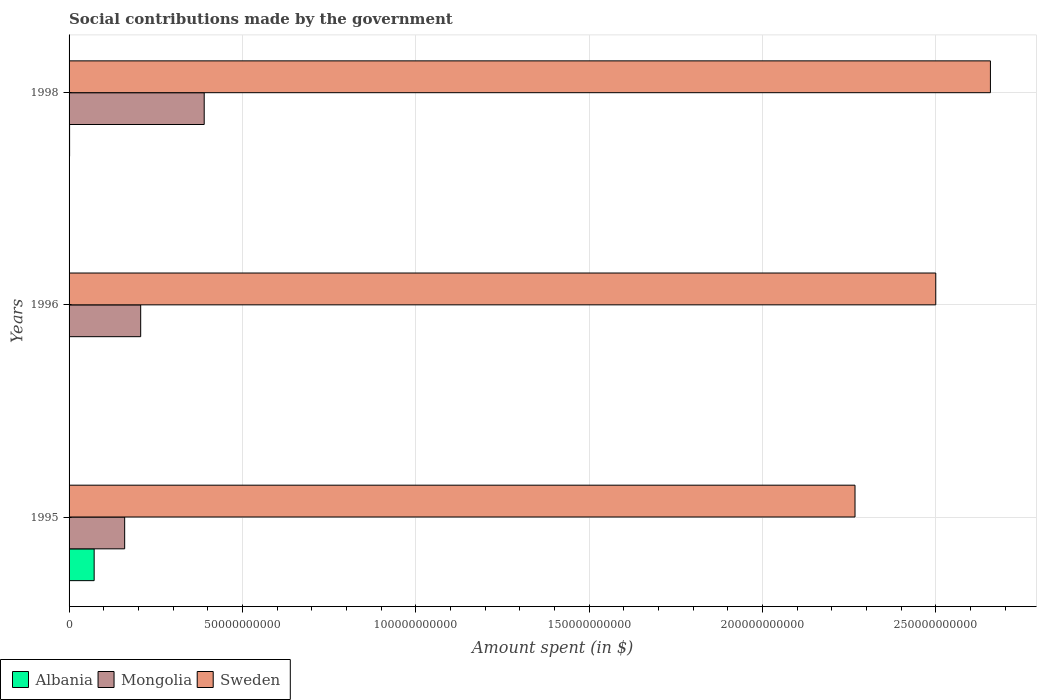How many different coloured bars are there?
Offer a terse response. 3. Are the number of bars per tick equal to the number of legend labels?
Your response must be concise. Yes. Are the number of bars on each tick of the Y-axis equal?
Your answer should be compact. Yes. What is the label of the 1st group of bars from the top?
Keep it short and to the point. 1998. In how many cases, is the number of bars for a given year not equal to the number of legend labels?
Your answer should be very brief. 0. What is the amount spent on social contributions in Mongolia in 1996?
Keep it short and to the point. 2.07e+1. Across all years, what is the maximum amount spent on social contributions in Albania?
Give a very brief answer. 7.24e+09. Across all years, what is the minimum amount spent on social contributions in Albania?
Make the answer very short. 2000. In which year was the amount spent on social contributions in Mongolia maximum?
Your answer should be compact. 1998. In which year was the amount spent on social contributions in Sweden minimum?
Provide a short and direct response. 1995. What is the total amount spent on social contributions in Albania in the graph?
Provide a short and direct response. 7.39e+09. What is the difference between the amount spent on social contributions in Albania in 1996 and that in 1998?
Keep it short and to the point. -1.51e+08. What is the difference between the amount spent on social contributions in Albania in 1998 and the amount spent on social contributions in Mongolia in 1995?
Offer a terse response. -1.59e+1. What is the average amount spent on social contributions in Sweden per year?
Your response must be concise. 2.48e+11. In the year 1996, what is the difference between the amount spent on social contributions in Sweden and amount spent on social contributions in Mongolia?
Your response must be concise. 2.29e+11. In how many years, is the amount spent on social contributions in Sweden greater than 50000000000 $?
Make the answer very short. 3. What is the ratio of the amount spent on social contributions in Albania in 1995 to that in 1996?
Provide a succinct answer. 3.62e+06. Is the amount spent on social contributions in Albania in 1995 less than that in 1996?
Keep it short and to the point. No. Is the difference between the amount spent on social contributions in Sweden in 1995 and 1996 greater than the difference between the amount spent on social contributions in Mongolia in 1995 and 1996?
Offer a terse response. No. What is the difference between the highest and the second highest amount spent on social contributions in Mongolia?
Your response must be concise. 1.83e+1. What is the difference between the highest and the lowest amount spent on social contributions in Albania?
Offer a very short reply. 7.24e+09. What does the 2nd bar from the top in 1998 represents?
Your answer should be very brief. Mongolia. What does the 3rd bar from the bottom in 1995 represents?
Offer a very short reply. Sweden. Is it the case that in every year, the sum of the amount spent on social contributions in Sweden and amount spent on social contributions in Mongolia is greater than the amount spent on social contributions in Albania?
Make the answer very short. Yes. How many bars are there?
Your answer should be very brief. 9. Are all the bars in the graph horizontal?
Ensure brevity in your answer.  Yes. What is the difference between two consecutive major ticks on the X-axis?
Ensure brevity in your answer.  5.00e+1. Are the values on the major ticks of X-axis written in scientific E-notation?
Provide a short and direct response. No. Does the graph contain any zero values?
Ensure brevity in your answer.  No. Does the graph contain grids?
Give a very brief answer. Yes. Where does the legend appear in the graph?
Your answer should be very brief. Bottom left. How are the legend labels stacked?
Make the answer very short. Horizontal. What is the title of the graph?
Your answer should be compact. Social contributions made by the government. Does "Haiti" appear as one of the legend labels in the graph?
Your answer should be very brief. No. What is the label or title of the X-axis?
Provide a succinct answer. Amount spent (in $). What is the Amount spent (in $) in Albania in 1995?
Offer a very short reply. 7.24e+09. What is the Amount spent (in $) of Mongolia in 1995?
Your response must be concise. 1.60e+1. What is the Amount spent (in $) in Sweden in 1995?
Your response must be concise. 2.27e+11. What is the Amount spent (in $) in Albania in 1996?
Your answer should be compact. 2000. What is the Amount spent (in $) of Mongolia in 1996?
Keep it short and to the point. 2.07e+1. What is the Amount spent (in $) of Sweden in 1996?
Keep it short and to the point. 2.50e+11. What is the Amount spent (in $) in Albania in 1998?
Offer a very short reply. 1.51e+08. What is the Amount spent (in $) of Mongolia in 1998?
Ensure brevity in your answer.  3.90e+1. What is the Amount spent (in $) of Sweden in 1998?
Offer a terse response. 2.66e+11. Across all years, what is the maximum Amount spent (in $) in Albania?
Ensure brevity in your answer.  7.24e+09. Across all years, what is the maximum Amount spent (in $) in Mongolia?
Your response must be concise. 3.90e+1. Across all years, what is the maximum Amount spent (in $) of Sweden?
Keep it short and to the point. 2.66e+11. Across all years, what is the minimum Amount spent (in $) of Albania?
Provide a short and direct response. 2000. Across all years, what is the minimum Amount spent (in $) of Mongolia?
Offer a very short reply. 1.60e+1. Across all years, what is the minimum Amount spent (in $) of Sweden?
Your answer should be very brief. 2.27e+11. What is the total Amount spent (in $) in Albania in the graph?
Keep it short and to the point. 7.39e+09. What is the total Amount spent (in $) of Mongolia in the graph?
Give a very brief answer. 7.57e+1. What is the total Amount spent (in $) in Sweden in the graph?
Your answer should be very brief. 7.43e+11. What is the difference between the Amount spent (in $) in Albania in 1995 and that in 1996?
Keep it short and to the point. 7.24e+09. What is the difference between the Amount spent (in $) in Mongolia in 1995 and that in 1996?
Offer a terse response. -4.62e+09. What is the difference between the Amount spent (in $) of Sweden in 1995 and that in 1996?
Make the answer very short. -2.33e+1. What is the difference between the Amount spent (in $) of Albania in 1995 and that in 1998?
Offer a terse response. 7.09e+09. What is the difference between the Amount spent (in $) in Mongolia in 1995 and that in 1998?
Offer a very short reply. -2.29e+1. What is the difference between the Amount spent (in $) of Sweden in 1995 and that in 1998?
Your answer should be very brief. -3.91e+1. What is the difference between the Amount spent (in $) of Albania in 1996 and that in 1998?
Keep it short and to the point. -1.51e+08. What is the difference between the Amount spent (in $) in Mongolia in 1996 and that in 1998?
Give a very brief answer. -1.83e+1. What is the difference between the Amount spent (in $) of Sweden in 1996 and that in 1998?
Keep it short and to the point. -1.58e+1. What is the difference between the Amount spent (in $) in Albania in 1995 and the Amount spent (in $) in Mongolia in 1996?
Your answer should be compact. -1.34e+1. What is the difference between the Amount spent (in $) of Albania in 1995 and the Amount spent (in $) of Sweden in 1996?
Your answer should be very brief. -2.43e+11. What is the difference between the Amount spent (in $) in Mongolia in 1995 and the Amount spent (in $) in Sweden in 1996?
Provide a short and direct response. -2.34e+11. What is the difference between the Amount spent (in $) in Albania in 1995 and the Amount spent (in $) in Mongolia in 1998?
Offer a terse response. -3.17e+1. What is the difference between the Amount spent (in $) of Albania in 1995 and the Amount spent (in $) of Sweden in 1998?
Give a very brief answer. -2.59e+11. What is the difference between the Amount spent (in $) in Mongolia in 1995 and the Amount spent (in $) in Sweden in 1998?
Ensure brevity in your answer.  -2.50e+11. What is the difference between the Amount spent (in $) in Albania in 1996 and the Amount spent (in $) in Mongolia in 1998?
Offer a very short reply. -3.90e+1. What is the difference between the Amount spent (in $) of Albania in 1996 and the Amount spent (in $) of Sweden in 1998?
Your answer should be compact. -2.66e+11. What is the difference between the Amount spent (in $) of Mongolia in 1996 and the Amount spent (in $) of Sweden in 1998?
Ensure brevity in your answer.  -2.45e+11. What is the average Amount spent (in $) in Albania per year?
Provide a short and direct response. 2.46e+09. What is the average Amount spent (in $) in Mongolia per year?
Provide a short and direct response. 2.52e+1. What is the average Amount spent (in $) in Sweden per year?
Your response must be concise. 2.48e+11. In the year 1995, what is the difference between the Amount spent (in $) of Albania and Amount spent (in $) of Mongolia?
Your answer should be very brief. -8.80e+09. In the year 1995, what is the difference between the Amount spent (in $) of Albania and Amount spent (in $) of Sweden?
Offer a very short reply. -2.19e+11. In the year 1995, what is the difference between the Amount spent (in $) in Mongolia and Amount spent (in $) in Sweden?
Your answer should be compact. -2.11e+11. In the year 1996, what is the difference between the Amount spent (in $) in Albania and Amount spent (in $) in Mongolia?
Provide a succinct answer. -2.07e+1. In the year 1996, what is the difference between the Amount spent (in $) in Albania and Amount spent (in $) in Sweden?
Your answer should be compact. -2.50e+11. In the year 1996, what is the difference between the Amount spent (in $) of Mongolia and Amount spent (in $) of Sweden?
Your response must be concise. -2.29e+11. In the year 1998, what is the difference between the Amount spent (in $) in Albania and Amount spent (in $) in Mongolia?
Ensure brevity in your answer.  -3.88e+1. In the year 1998, what is the difference between the Amount spent (in $) in Albania and Amount spent (in $) in Sweden?
Offer a very short reply. -2.66e+11. In the year 1998, what is the difference between the Amount spent (in $) of Mongolia and Amount spent (in $) of Sweden?
Your answer should be compact. -2.27e+11. What is the ratio of the Amount spent (in $) in Albania in 1995 to that in 1996?
Keep it short and to the point. 3.62e+06. What is the ratio of the Amount spent (in $) of Mongolia in 1995 to that in 1996?
Provide a short and direct response. 0.78. What is the ratio of the Amount spent (in $) in Sweden in 1995 to that in 1996?
Make the answer very short. 0.91. What is the ratio of the Amount spent (in $) in Albania in 1995 to that in 1998?
Offer a very short reply. 48.03. What is the ratio of the Amount spent (in $) in Mongolia in 1995 to that in 1998?
Make the answer very short. 0.41. What is the ratio of the Amount spent (in $) in Sweden in 1995 to that in 1998?
Offer a very short reply. 0.85. What is the ratio of the Amount spent (in $) of Mongolia in 1996 to that in 1998?
Offer a terse response. 0.53. What is the ratio of the Amount spent (in $) in Sweden in 1996 to that in 1998?
Your response must be concise. 0.94. What is the difference between the highest and the second highest Amount spent (in $) of Albania?
Offer a terse response. 7.09e+09. What is the difference between the highest and the second highest Amount spent (in $) in Mongolia?
Make the answer very short. 1.83e+1. What is the difference between the highest and the second highest Amount spent (in $) of Sweden?
Make the answer very short. 1.58e+1. What is the difference between the highest and the lowest Amount spent (in $) of Albania?
Provide a short and direct response. 7.24e+09. What is the difference between the highest and the lowest Amount spent (in $) of Mongolia?
Provide a short and direct response. 2.29e+1. What is the difference between the highest and the lowest Amount spent (in $) in Sweden?
Offer a terse response. 3.91e+1. 